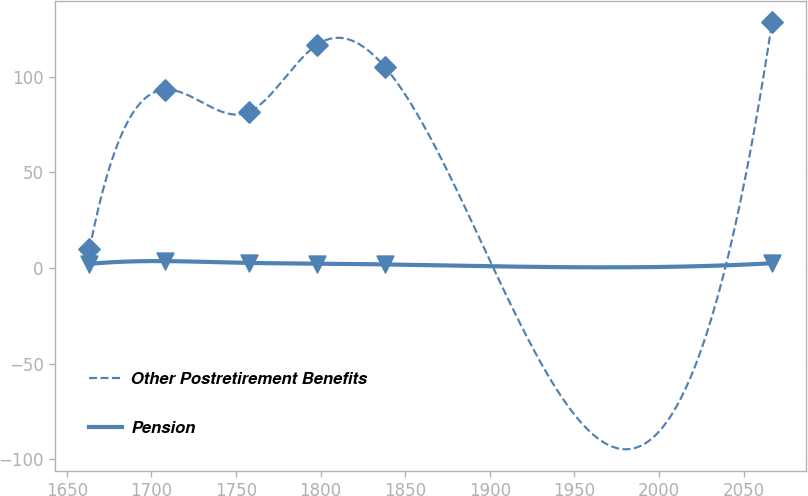Convert chart to OTSL. <chart><loc_0><loc_0><loc_500><loc_500><line_chart><ecel><fcel>Other Postretirement Benefits<fcel>Pension<nl><fcel>1663.46<fcel>9.85<fcel>2.09<nl><fcel>1708.05<fcel>93.12<fcel>3.54<nl><fcel>1757.49<fcel>81.4<fcel>2.6<nl><fcel>1797.82<fcel>116.56<fcel>2.26<nl><fcel>1838.15<fcel>104.84<fcel>1.82<nl><fcel>2066.75<fcel>128.28<fcel>2.43<nl></chart> 